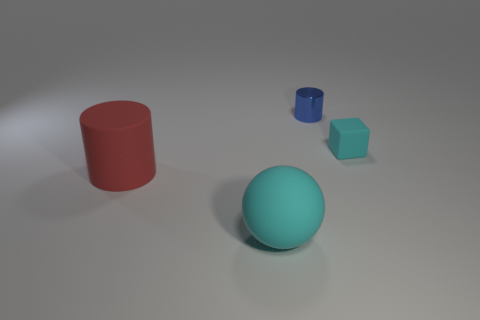Subtract all red cylinders. How many cylinders are left? 1 Add 3 purple metal cylinders. How many objects exist? 7 Subtract 2 cylinders. How many cylinders are left? 0 Subtract all red cubes. How many red cylinders are left? 1 Add 1 small cyan objects. How many small cyan objects are left? 2 Add 3 large blue shiny balls. How many large blue shiny balls exist? 3 Subtract 0 red balls. How many objects are left? 4 Subtract all cubes. How many objects are left? 3 Subtract all purple blocks. Subtract all blue balls. How many blocks are left? 1 Subtract all small cyan things. Subtract all small brown shiny things. How many objects are left? 3 